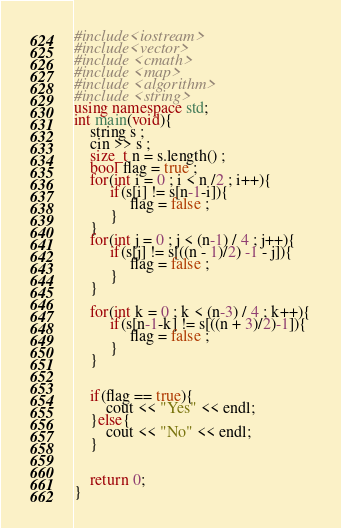<code> <loc_0><loc_0><loc_500><loc_500><_C++_>#include<iostream>
#include<vector>
#include <cmath>
#include <map>
#include <algorithm>
#include <string>
using namespace std;
int main(void){
    string s ;
    cin >> s ;
    size_t n = s.length() ;
    bool flag = true ;
    for(int i = 0 ; i < n /2 ; i++){
         if(s[i] != s[n-1-i]){
              flag = false ;
         }
    }
    for(int j = 0 ; j < (n-1) / 4 ; j++){
         if(s[j] != s[((n - 1)/2) -1 - j]){
              flag = false ;
         }
    }

    for(int k = 0 ; k < (n-3) / 4 ; k++){
         if(s[n-1-k] != s[((n + 3)/2)-1]){
              flag = false ;
         }
    }


    if(flag == true){
        cout << "Yes" << endl;
    }else{
        cout << "No" << endl;
    }


    return 0;
}</code> 